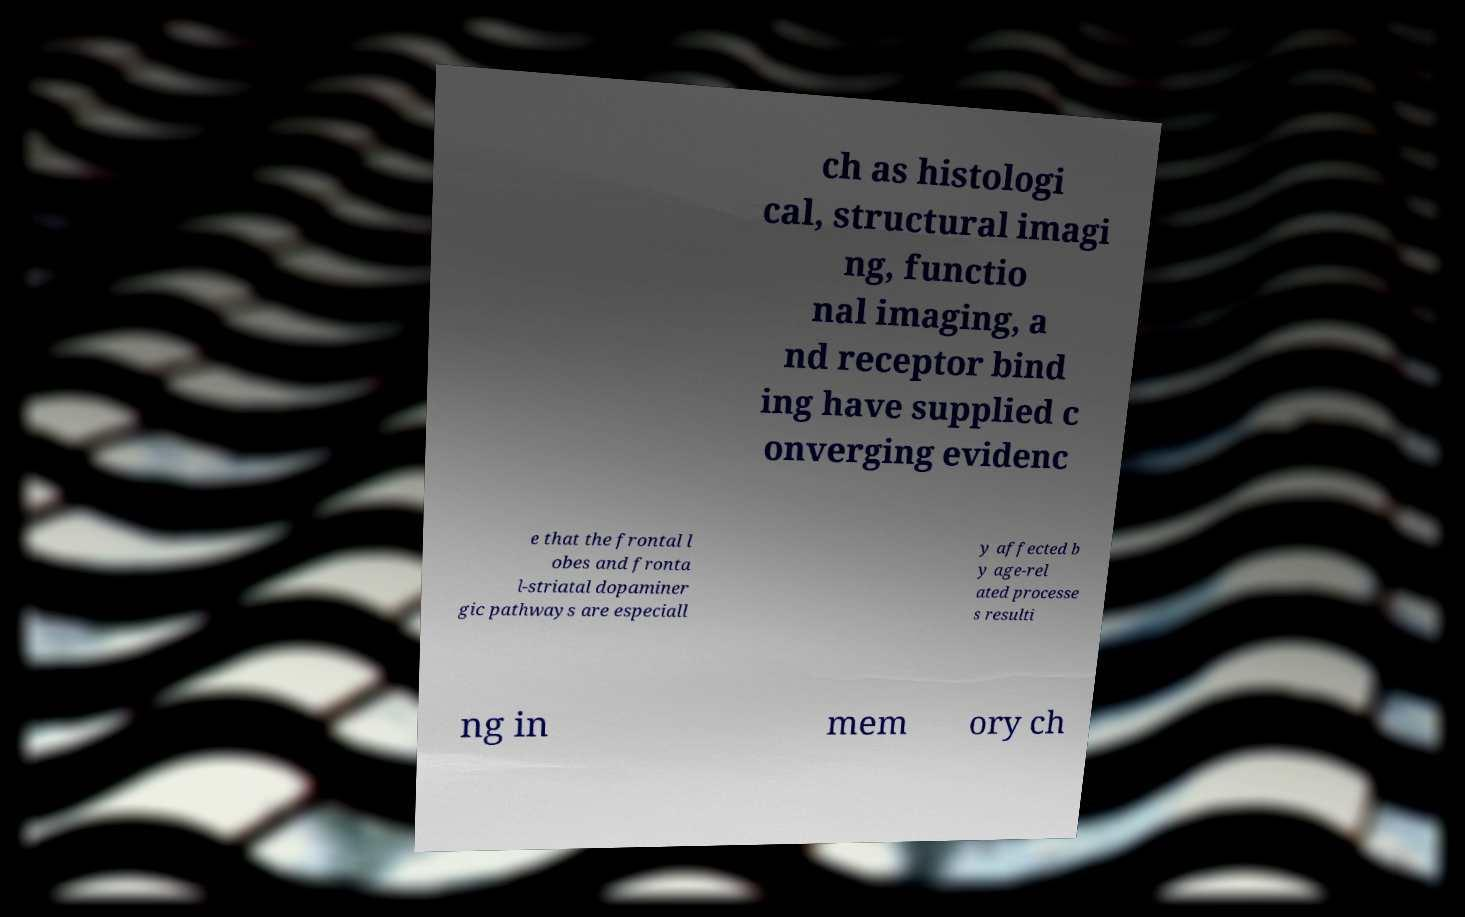Please identify and transcribe the text found in this image. ch as histologi cal, structural imagi ng, functio nal imaging, a nd receptor bind ing have supplied c onverging evidenc e that the frontal l obes and fronta l-striatal dopaminer gic pathways are especiall y affected b y age-rel ated processe s resulti ng in mem ory ch 